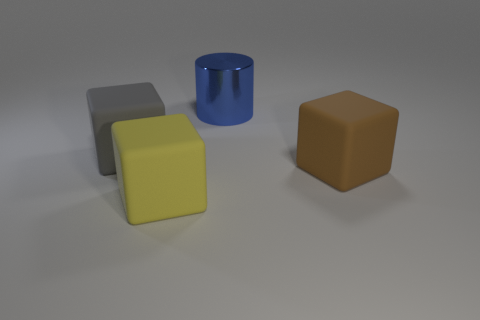Are these objects capable of interacting with each other? They appear to be separate, static objects in a scene designed for visualization. Without external forces in this static image, they would not interact with each other. 